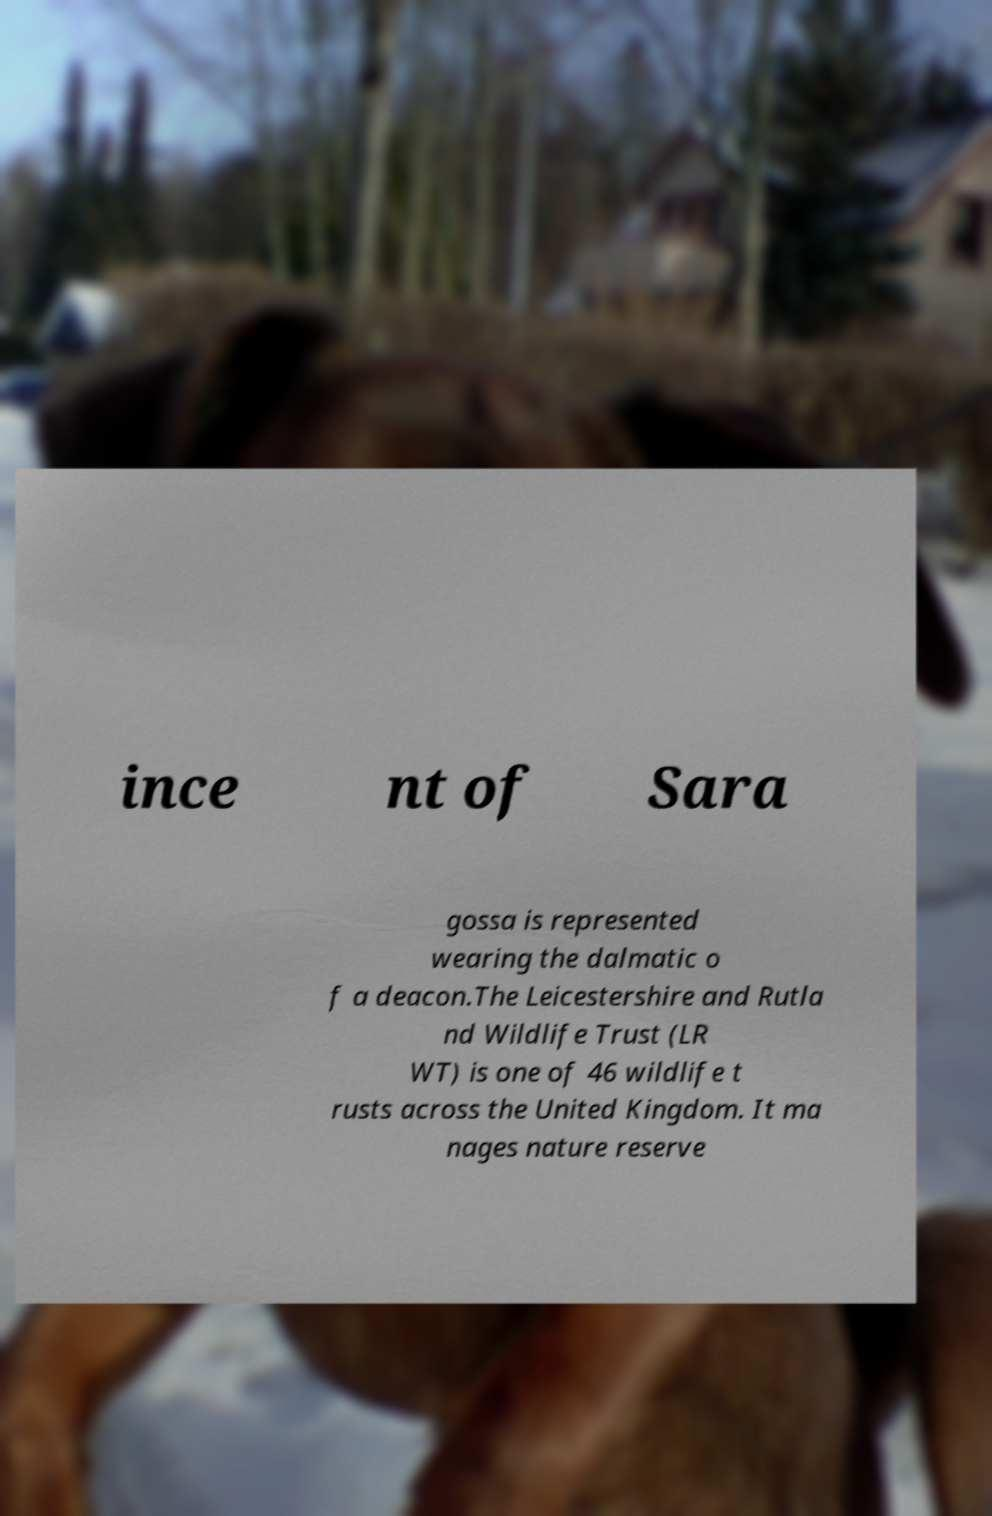For documentation purposes, I need the text within this image transcribed. Could you provide that? ince nt of Sara gossa is represented wearing the dalmatic o f a deacon.The Leicestershire and Rutla nd Wildlife Trust (LR WT) is one of 46 wildlife t rusts across the United Kingdom. It ma nages nature reserve 